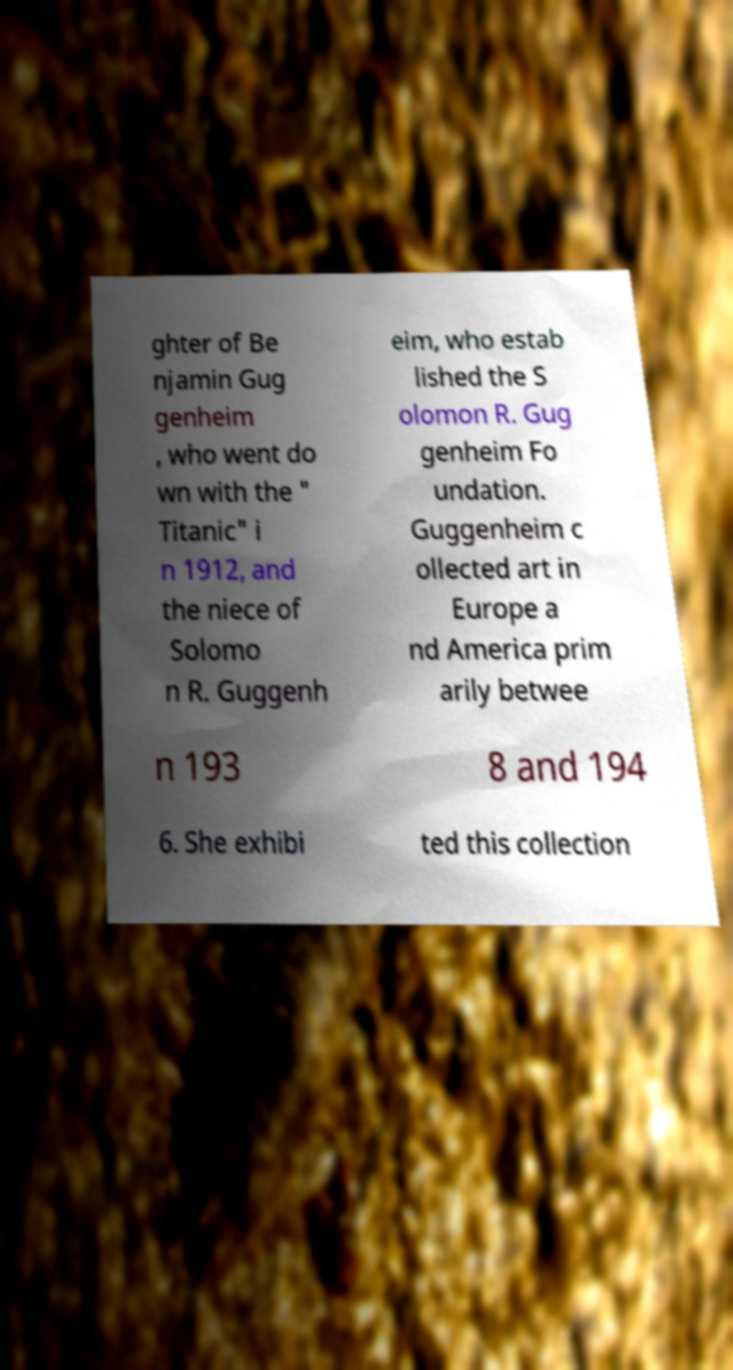Could you extract and type out the text from this image? ghter of Be njamin Gug genheim , who went do wn with the " Titanic" i n 1912, and the niece of Solomo n R. Guggenh eim, who estab lished the S olomon R. Gug genheim Fo undation. Guggenheim c ollected art in Europe a nd America prim arily betwee n 193 8 and 194 6. She exhibi ted this collection 